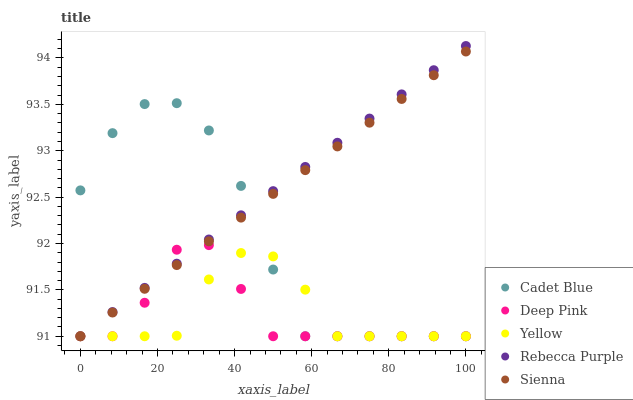Does Deep Pink have the minimum area under the curve?
Answer yes or no. Yes. Does Rebecca Purple have the maximum area under the curve?
Answer yes or no. Yes. Does Cadet Blue have the minimum area under the curve?
Answer yes or no. No. Does Cadet Blue have the maximum area under the curve?
Answer yes or no. No. Is Sienna the smoothest?
Answer yes or no. Yes. Is Cadet Blue the roughest?
Answer yes or no. Yes. Is Yellow the smoothest?
Answer yes or no. No. Is Yellow the roughest?
Answer yes or no. No. Does Sienna have the lowest value?
Answer yes or no. Yes. Does Rebecca Purple have the highest value?
Answer yes or no. Yes. Does Cadet Blue have the highest value?
Answer yes or no. No. Does Sienna intersect Yellow?
Answer yes or no. Yes. Is Sienna less than Yellow?
Answer yes or no. No. Is Sienna greater than Yellow?
Answer yes or no. No. 